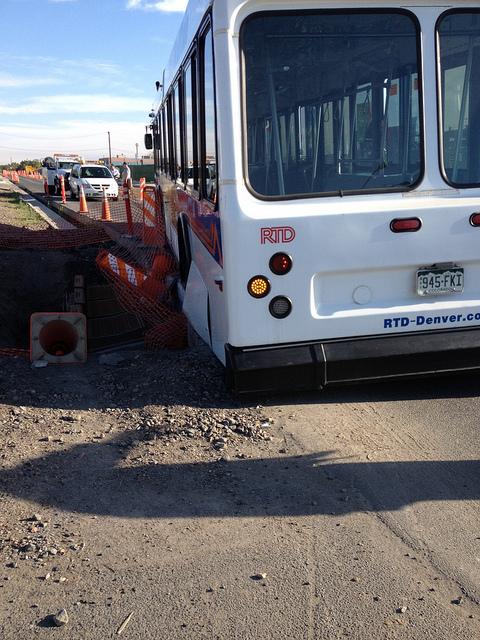What color is the sky?
Answer briefly. Blue. What is the color of the bus?
Concise answer only. White. Are there orange cones?
Short answer required. Yes. 